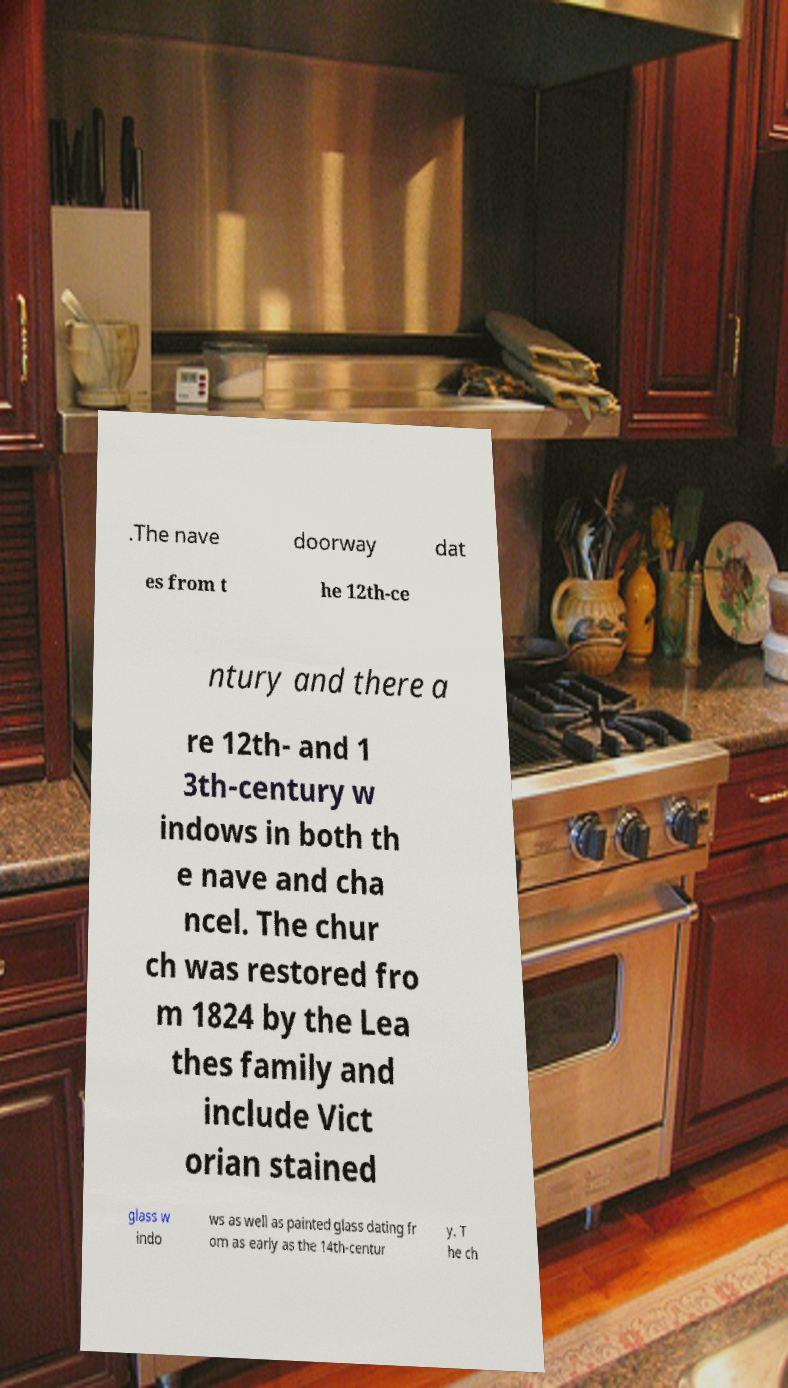Please read and relay the text visible in this image. What does it say? .The nave doorway dat es from t he 12th-ce ntury and there a re 12th- and 1 3th-century w indows in both th e nave and cha ncel. The chur ch was restored fro m 1824 by the Lea thes family and include Vict orian stained glass w indo ws as well as painted glass dating fr om as early as the 14th-centur y. T he ch 